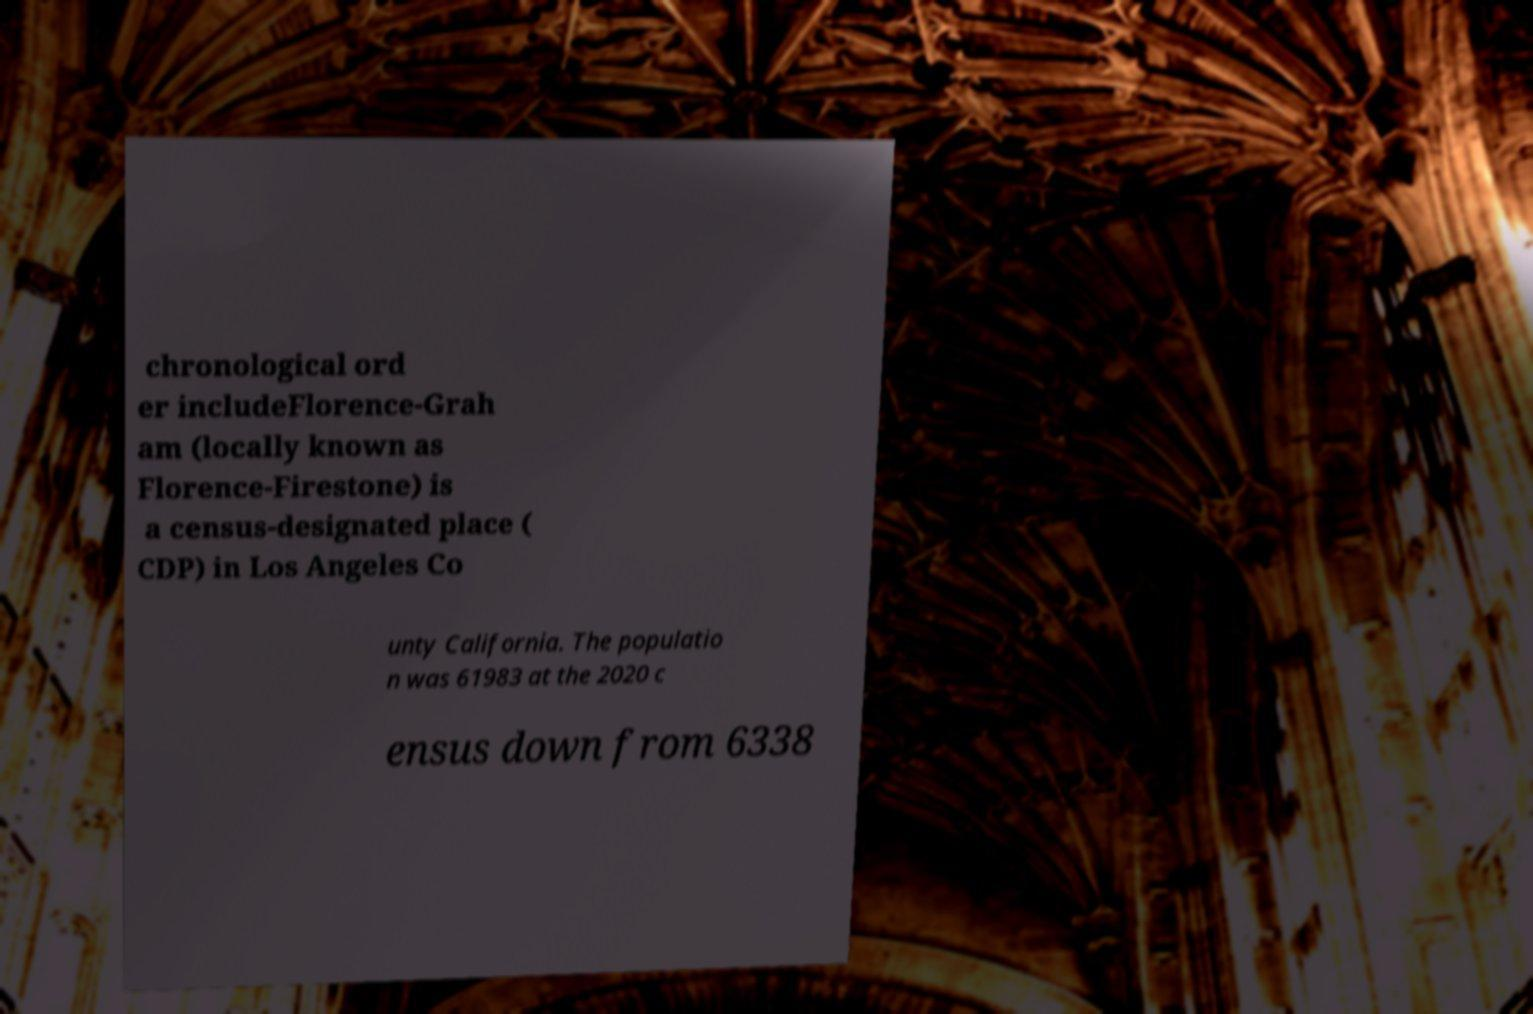Can you read and provide the text displayed in the image?This photo seems to have some interesting text. Can you extract and type it out for me? chronological ord er includeFlorence-Grah am (locally known as Florence-Firestone) is a census-designated place ( CDP) in Los Angeles Co unty California. The populatio n was 61983 at the 2020 c ensus down from 6338 